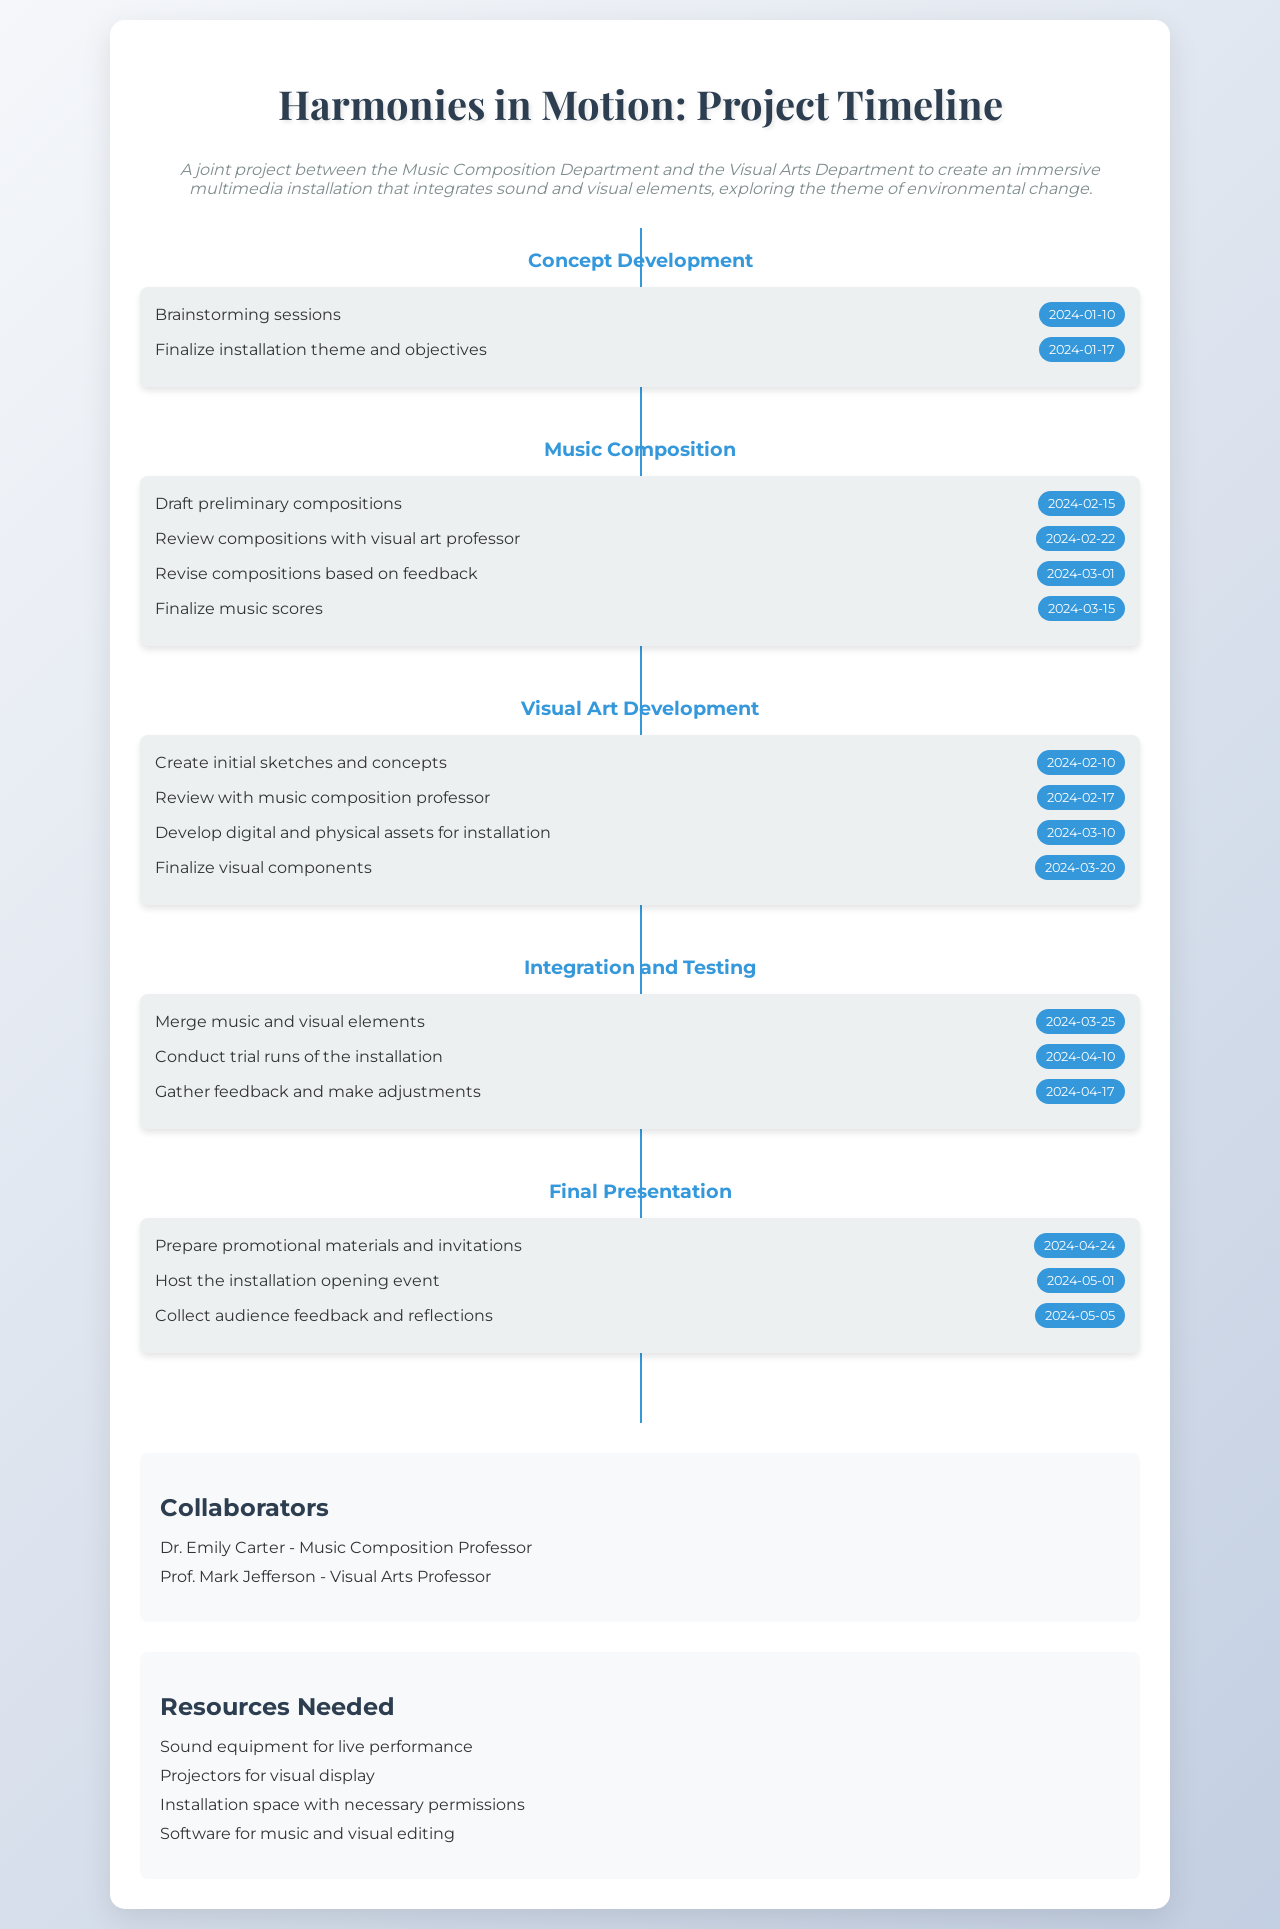What is the final deadline for the music scores? The final deadline for music scores is indicated in the Music Composition phase, which states it is due on March 15, 2024.
Answer: March 15, 2024 Who is the visual arts professor collaborating on the project? The collaborators section lists Prof. Mark Jefferson as the Visual Arts Professor.
Answer: Prof. Mark Jefferson What date is the installation opening event scheduled for? The date for the installation opening event is mentioned in the Final Presentation phase, which is May 1, 2024.
Answer: May 1, 2024 What is the deadline for gathering feedback and making adjustments? The deadline for gathering feedback is specified in the Integration and Testing phase, which is April 17, 2024.
Answer: April 17, 2024 When will the review with the music composition professor take place? The review with the music composition professor is scheduled for February 17, 2024, as indicated in the Visual Art Development phase.
Answer: February 17, 2024 What is the purpose of the brainstorming sessions? The brainstorming sessions are part of the Concept Development phase to help shape the project's theme and objectives.
Answer: Concept Development What is the main theme being explored in this multimedia installation? The project's overview indicates the theme being explored is environmental change.
Answer: Environmental change In which phase do the initial sketches and concepts get created? The creation of initial sketches and concepts occurs in the Visual Art Development phase.
Answer: Visual Art Development How many activities are listed in the Integration and Testing phase? The Integration and Testing phase lists three activities focused on merging elements and conducting trials.
Answer: Three activities 